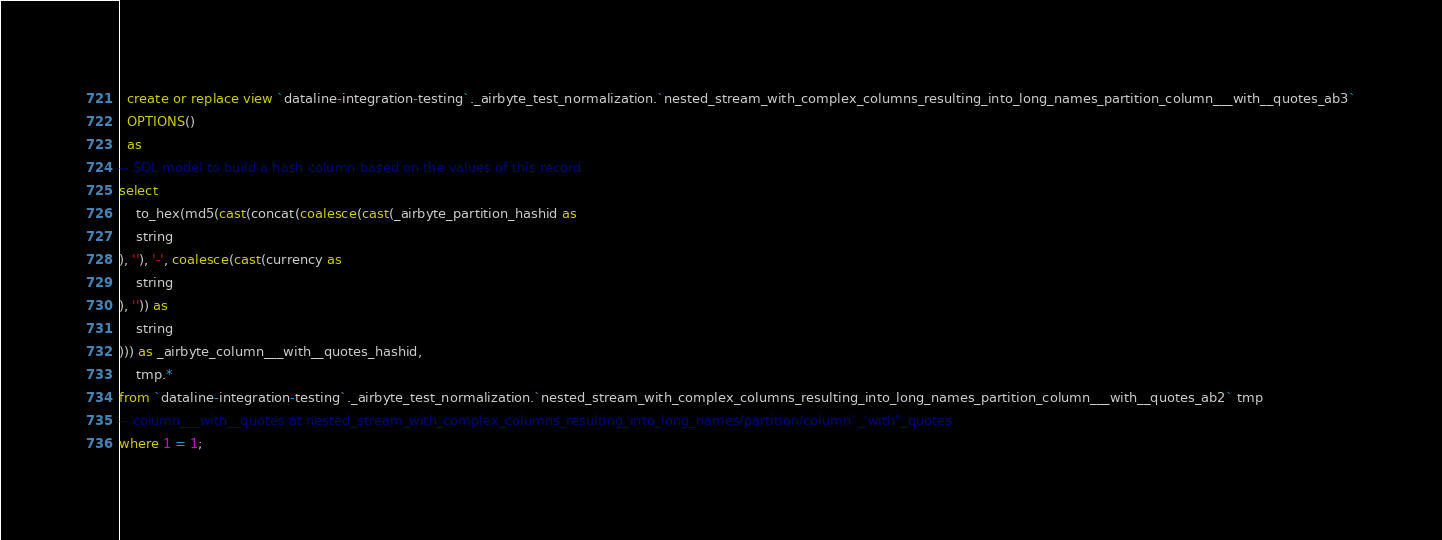<code> <loc_0><loc_0><loc_500><loc_500><_SQL_>

  create or replace view `dataline-integration-testing`._airbyte_test_normalization.`nested_stream_with_complex_columns_resulting_into_long_names_partition_column___with__quotes_ab3`
  OPTIONS()
  as 
-- SQL model to build a hash column based on the values of this record
select
    to_hex(md5(cast(concat(coalesce(cast(_airbyte_partition_hashid as 
    string
), ''), '-', coalesce(cast(currency as 
    string
), '')) as 
    string
))) as _airbyte_column___with__quotes_hashid,
    tmp.*
from `dataline-integration-testing`._airbyte_test_normalization.`nested_stream_with_complex_columns_resulting_into_long_names_partition_column___with__quotes_ab2` tmp
-- column___with__quotes at nested_stream_with_complex_columns_resulting_into_long_names/partition/column`_'with"_quotes
where 1 = 1;

</code> 